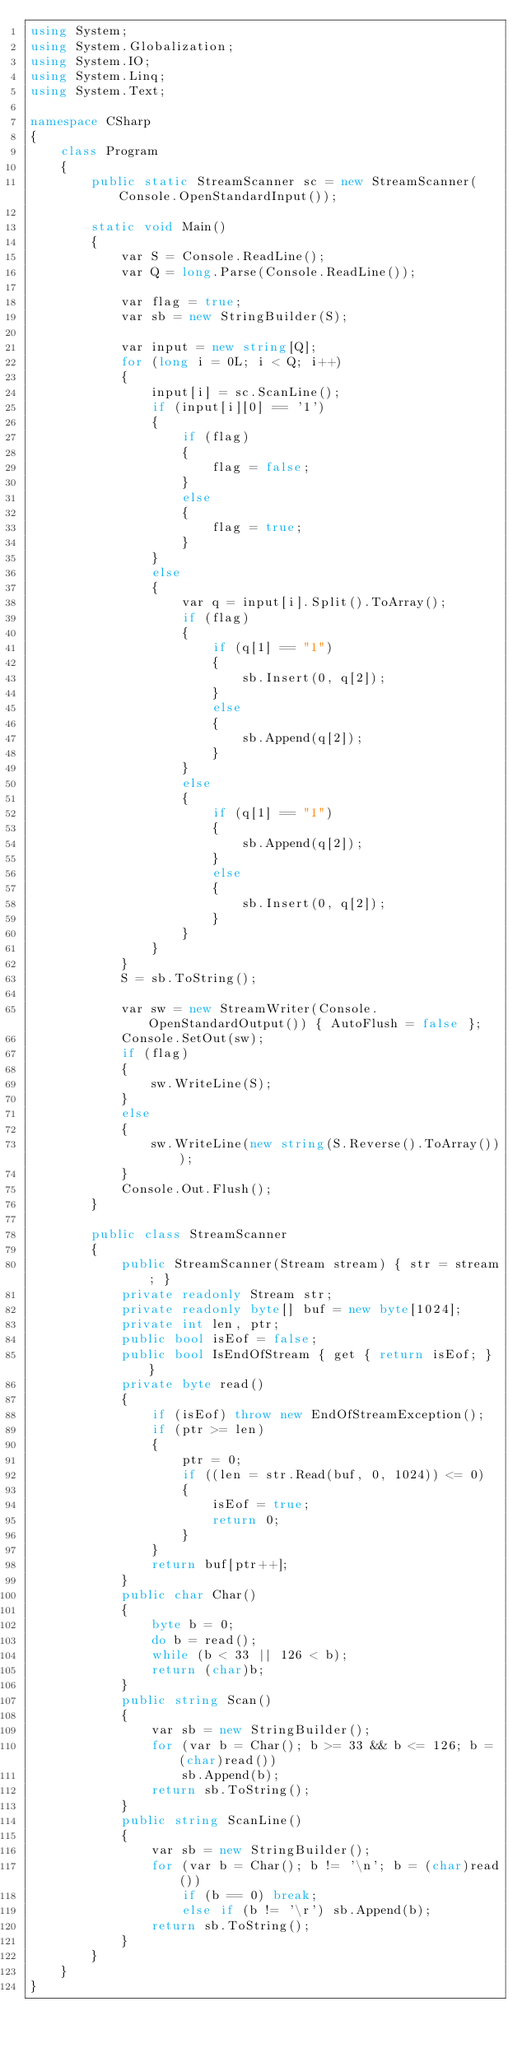<code> <loc_0><loc_0><loc_500><loc_500><_C#_>using System;
using System.Globalization;
using System.IO;
using System.Linq;
using System.Text;

namespace CSharp
{
    class Program
    {
        public static StreamScanner sc = new StreamScanner(Console.OpenStandardInput());

        static void Main()
        {
            var S = Console.ReadLine();
            var Q = long.Parse(Console.ReadLine());

            var flag = true;
            var sb = new StringBuilder(S);

            var input = new string[Q];
            for (long i = 0L; i < Q; i++)
            {
                input[i] = sc.ScanLine();
                if (input[i][0] == '1')
                {
                    if (flag)
                    {
                        flag = false;
                    }
                    else
                    {
                        flag = true;
                    }
                }
                else
                {
                    var q = input[i].Split().ToArray();
                    if (flag)
                    {
                        if (q[1] == "1")
                        {
                            sb.Insert(0, q[2]);
                        }
                        else
                        {
                            sb.Append(q[2]);
                        }
                    }
                    else
                    {
                        if (q[1] == "1")
                        {
                            sb.Append(q[2]);
                        }
                        else
                        {
                            sb.Insert(0, q[2]);
                        }
                    }
                }
            }
            S = sb.ToString();

            var sw = new StreamWriter(Console.OpenStandardOutput()) { AutoFlush = false };
            Console.SetOut(sw);
            if (flag)
            {
                sw.WriteLine(S);
            }
            else
            {
                sw.WriteLine(new string(S.Reverse().ToArray()));
            }
            Console.Out.Flush();
        }

        public class StreamScanner
        {
            public StreamScanner(Stream stream) { str = stream; }
            private readonly Stream str;
            private readonly byte[] buf = new byte[1024];
            private int len, ptr;
            public bool isEof = false;
            public bool IsEndOfStream { get { return isEof; } }
            private byte read()
            {
                if (isEof) throw new EndOfStreamException();
                if (ptr >= len)
                {
                    ptr = 0;
                    if ((len = str.Read(buf, 0, 1024)) <= 0)
                    {
                        isEof = true;
                        return 0;
                    }
                }
                return buf[ptr++];
            }
            public char Char()
            {
                byte b = 0;
                do b = read();
                while (b < 33 || 126 < b);
                return (char)b;
            }
            public string Scan()
            {
                var sb = new StringBuilder();
                for (var b = Char(); b >= 33 && b <= 126; b = (char)read())
                    sb.Append(b);
                return sb.ToString();
            }
            public string ScanLine()
            {
                var sb = new StringBuilder();
                for (var b = Char(); b != '\n'; b = (char)read())
                    if (b == 0) break;
                    else if (b != '\r') sb.Append(b);
                return sb.ToString();
            }
        }
    }
}</code> 